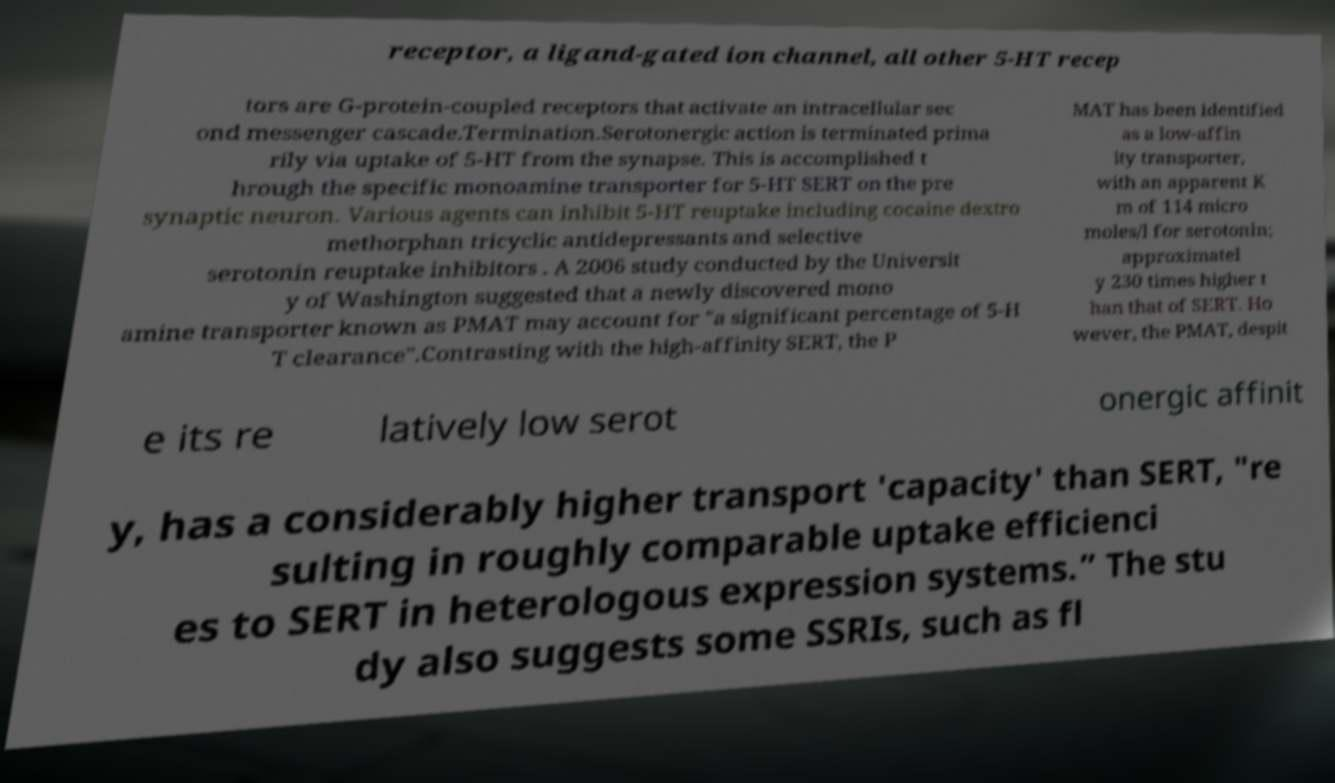Can you read and provide the text displayed in the image?This photo seems to have some interesting text. Can you extract and type it out for me? receptor, a ligand-gated ion channel, all other 5-HT recep tors are G-protein-coupled receptors that activate an intracellular sec ond messenger cascade.Termination.Serotonergic action is terminated prima rily via uptake of 5-HT from the synapse. This is accomplished t hrough the specific monoamine transporter for 5-HT SERT on the pre synaptic neuron. Various agents can inhibit 5-HT reuptake including cocaine dextro methorphan tricyclic antidepressants and selective serotonin reuptake inhibitors . A 2006 study conducted by the Universit y of Washington suggested that a newly discovered mono amine transporter known as PMAT may account for "a significant percentage of 5-H T clearance".Contrasting with the high-affinity SERT, the P MAT has been identified as a low-affin ity transporter, with an apparent K m of 114 micro moles/l for serotonin; approximatel y 230 times higher t han that of SERT. Ho wever, the PMAT, despit e its re latively low serot onergic affinit y, has a considerably higher transport 'capacity' than SERT, "re sulting in roughly comparable uptake efficienci es to SERT in heterologous expression systems.” The stu dy also suggests some SSRIs, such as fl 